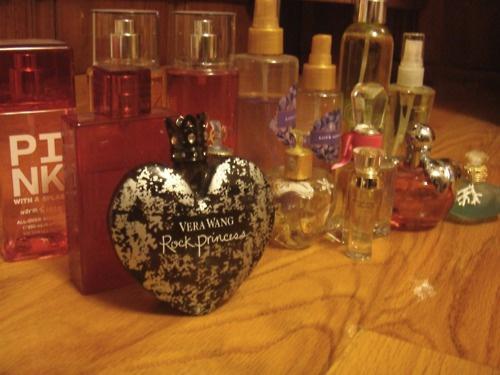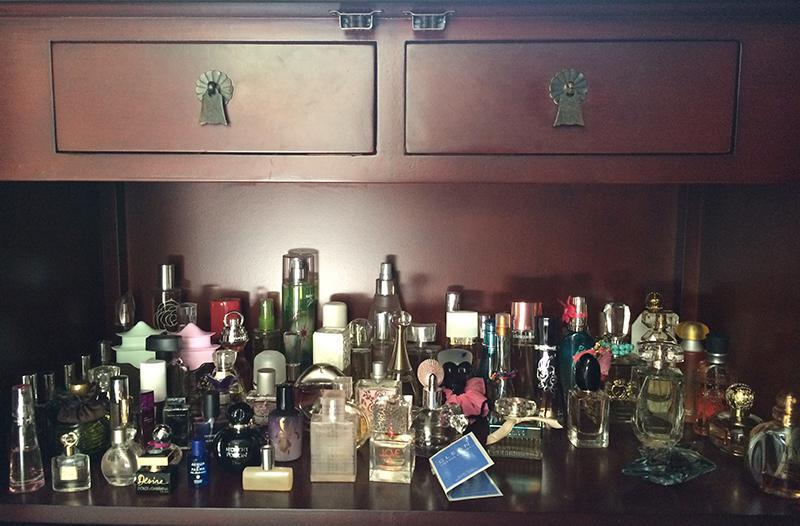The first image is the image on the left, the second image is the image on the right. Analyze the images presented: Is the assertion "The left image shows one glass fragrance bottle in a reflective glass display, and the right image shows a white shelf that angles up to the right and holds fragrance bottles." valid? Answer yes or no. No. The first image is the image on the left, the second image is the image on the right. Considering the images on both sides, is "There are at least ten perfumes in the left image." valid? Answer yes or no. Yes. 